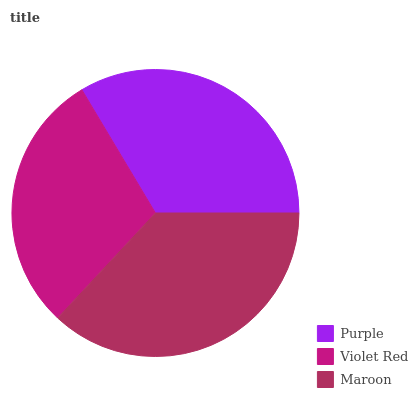Is Violet Red the minimum?
Answer yes or no. Yes. Is Maroon the maximum?
Answer yes or no. Yes. Is Maroon the minimum?
Answer yes or no. No. Is Violet Red the maximum?
Answer yes or no. No. Is Maroon greater than Violet Red?
Answer yes or no. Yes. Is Violet Red less than Maroon?
Answer yes or no. Yes. Is Violet Red greater than Maroon?
Answer yes or no. No. Is Maroon less than Violet Red?
Answer yes or no. No. Is Purple the high median?
Answer yes or no. Yes. Is Purple the low median?
Answer yes or no. Yes. Is Maroon the high median?
Answer yes or no. No. Is Violet Red the low median?
Answer yes or no. No. 